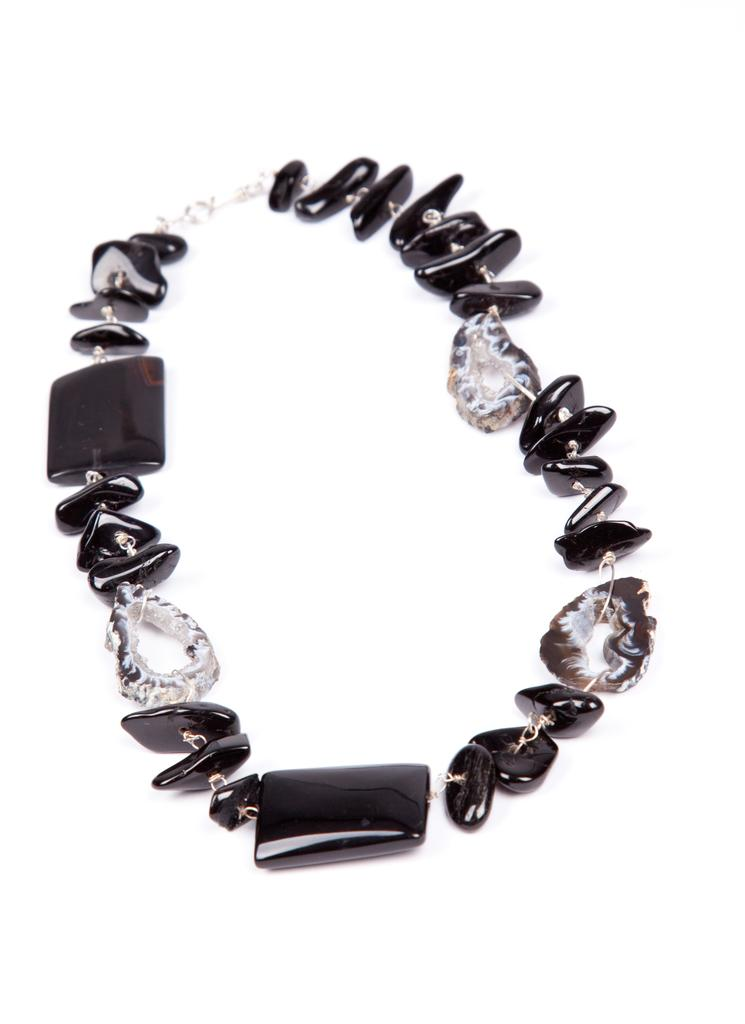What type of accessory is in the image? There is a bracelet in the image. What color are the stones on the bracelet? The bracelet has black stones. What type of material is used for the bracelet's structure? The bracelet has a chain. How many bells are attached to the bracelet in the image? There are no bells attached to the bracelet in the image; it only has black stones and a chain. 